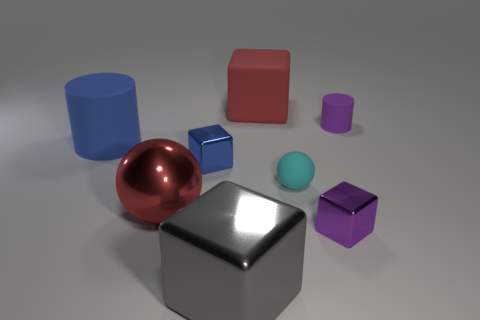Add 2 big red rubber blocks. How many objects exist? 10 Subtract all cylinders. How many objects are left? 6 Add 7 tiny yellow rubber balls. How many tiny yellow rubber balls exist? 7 Subtract 0 purple spheres. How many objects are left? 8 Subtract all small rubber balls. Subtract all purple matte cylinders. How many objects are left? 6 Add 3 small purple cubes. How many small purple cubes are left? 4 